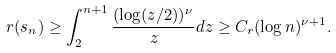<formula> <loc_0><loc_0><loc_500><loc_500>r ( s _ { n } ) \geq \int _ { 2 } ^ { n + 1 } \frac { ( \log ( z / 2 ) ) ^ { \nu } } { z } d z \geq C _ { r } ( \log n ) ^ { \nu + 1 } .</formula> 